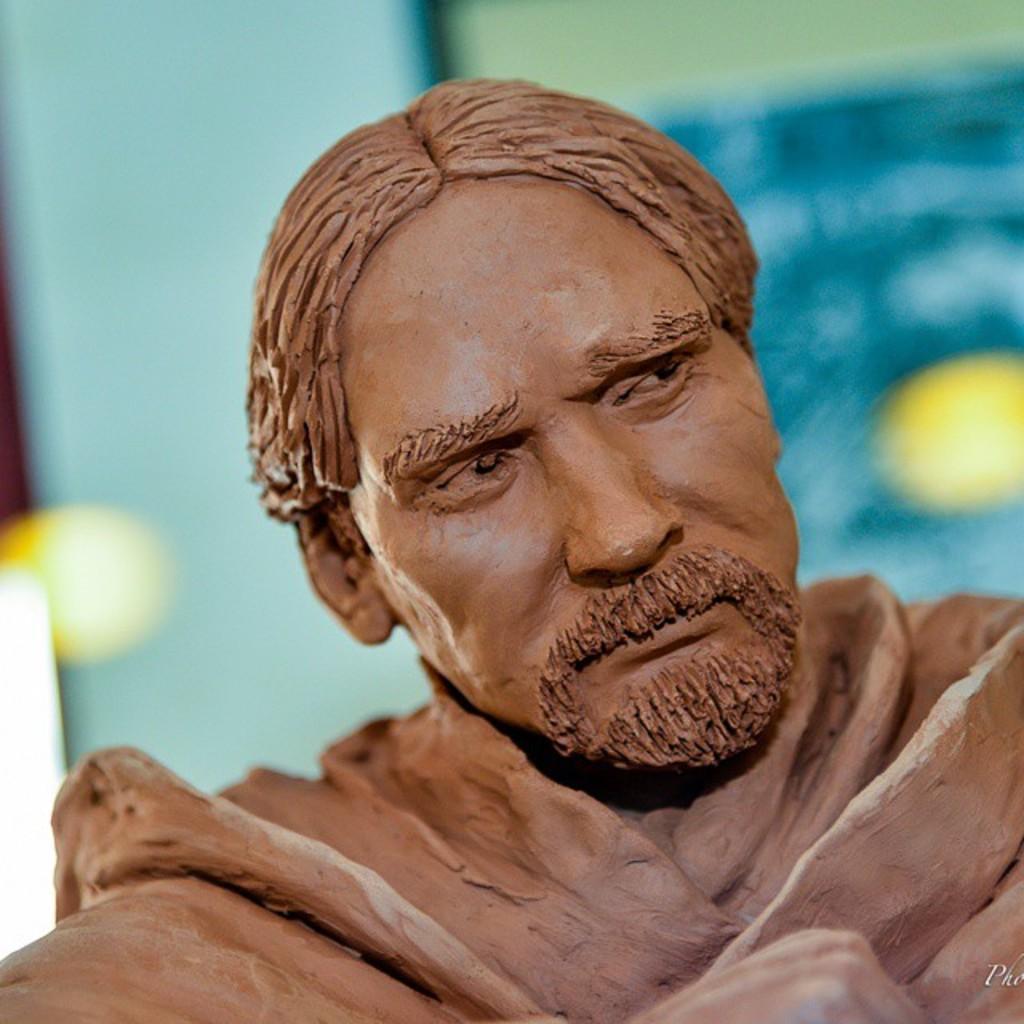Could you give a brief overview of what you see in this image? In this image we can see statue of a man. In the background it is blur. 